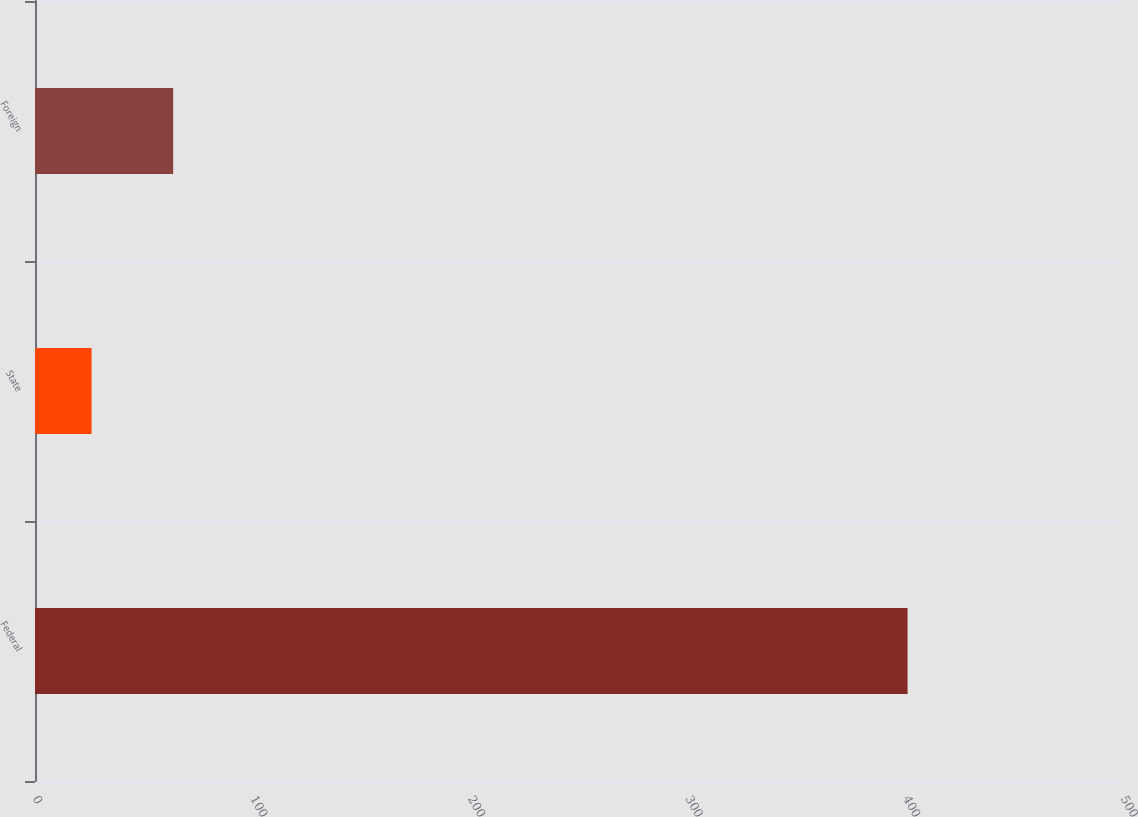Convert chart to OTSL. <chart><loc_0><loc_0><loc_500><loc_500><bar_chart><fcel>Federal<fcel>State<fcel>Foreign<nl><fcel>401<fcel>26<fcel>63.5<nl></chart> 